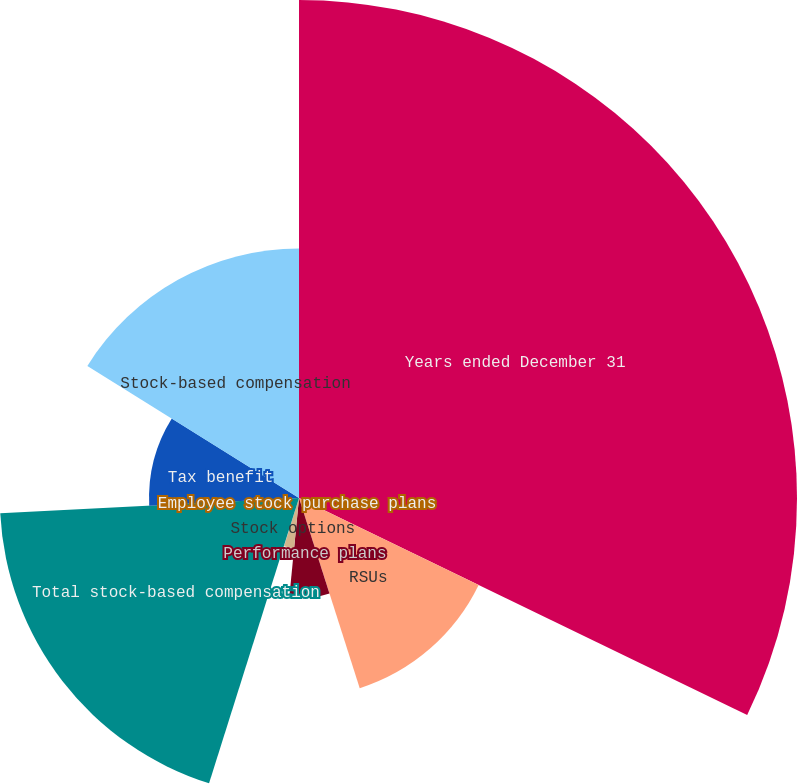Convert chart. <chart><loc_0><loc_0><loc_500><loc_500><pie_chart><fcel>Years ended December 31<fcel>RSUs<fcel>Performance plans<fcel>Stock options<fcel>Employee stock purchase plans<fcel>Total stock-based compensation<fcel>Tax benefit<fcel>Stock-based compensation<nl><fcel>32.18%<fcel>12.9%<fcel>6.47%<fcel>3.26%<fcel>0.05%<fcel>19.33%<fcel>9.69%<fcel>16.12%<nl></chart> 